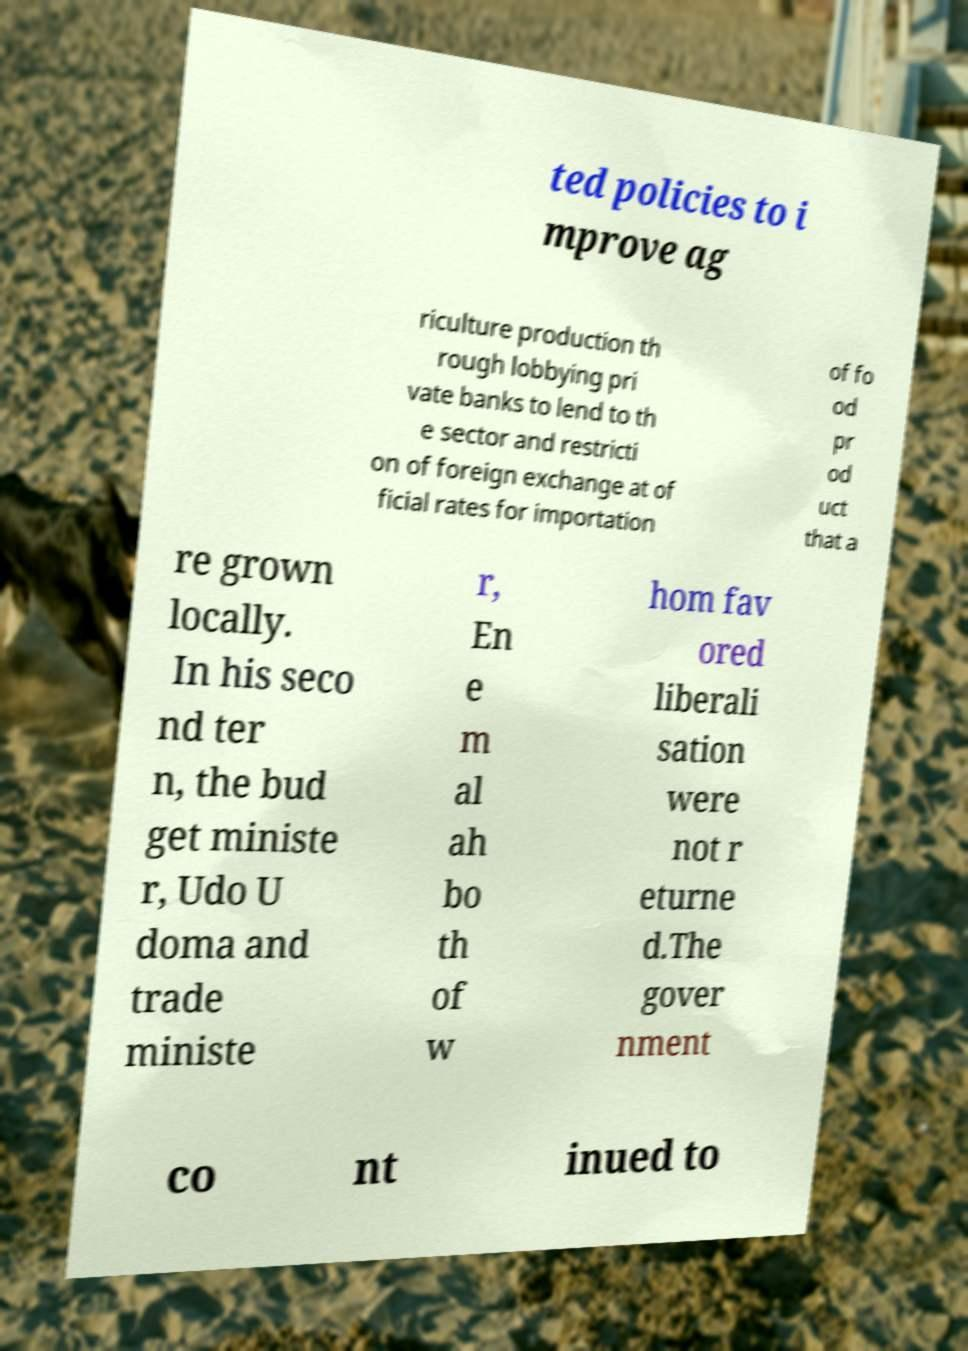What messages or text are displayed in this image? I need them in a readable, typed format. ted policies to i mprove ag riculture production th rough lobbying pri vate banks to lend to th e sector and restricti on of foreign exchange at of ficial rates for importation of fo od pr od uct that a re grown locally. In his seco nd ter n, the bud get ministe r, Udo U doma and trade ministe r, En e m al ah bo th of w hom fav ored liberali sation were not r eturne d.The gover nment co nt inued to 